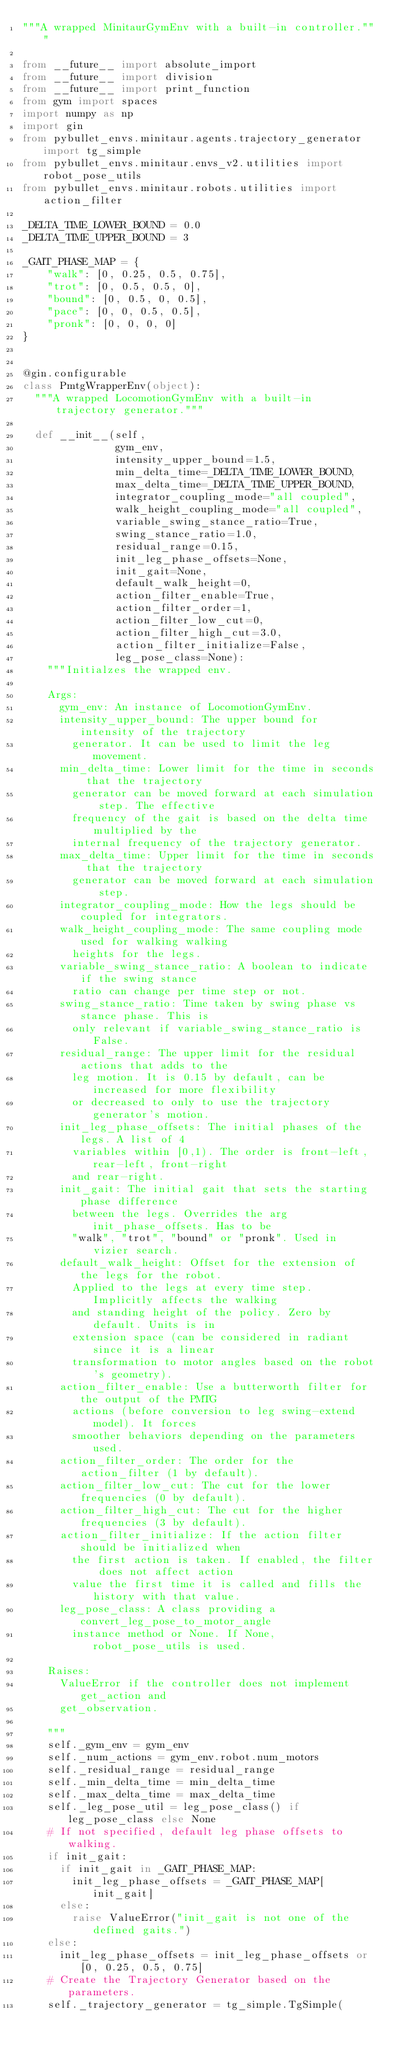<code> <loc_0><loc_0><loc_500><loc_500><_Python_>"""A wrapped MinitaurGymEnv with a built-in controller."""

from __future__ import absolute_import
from __future__ import division
from __future__ import print_function
from gym import spaces
import numpy as np
import gin
from pybullet_envs.minitaur.agents.trajectory_generator import tg_simple
from pybullet_envs.minitaur.envs_v2.utilities import robot_pose_utils
from pybullet_envs.minitaur.robots.utilities import action_filter

_DELTA_TIME_LOWER_BOUND = 0.0
_DELTA_TIME_UPPER_BOUND = 3

_GAIT_PHASE_MAP = {
    "walk": [0, 0.25, 0.5, 0.75],
    "trot": [0, 0.5, 0.5, 0],
    "bound": [0, 0.5, 0, 0.5],
    "pace": [0, 0, 0.5, 0.5],
    "pronk": [0, 0, 0, 0]
}


@gin.configurable
class PmtgWrapperEnv(object):
  """A wrapped LocomotionGymEnv with a built-in trajectory generator."""

  def __init__(self,
               gym_env,
               intensity_upper_bound=1.5,
               min_delta_time=_DELTA_TIME_LOWER_BOUND,
               max_delta_time=_DELTA_TIME_UPPER_BOUND,
               integrator_coupling_mode="all coupled",
               walk_height_coupling_mode="all coupled",
               variable_swing_stance_ratio=True,
               swing_stance_ratio=1.0,
               residual_range=0.15,
               init_leg_phase_offsets=None,
               init_gait=None,
               default_walk_height=0,
               action_filter_enable=True,
               action_filter_order=1,
               action_filter_low_cut=0,
               action_filter_high_cut=3.0,
               action_filter_initialize=False,
               leg_pose_class=None):
    """Initialzes the wrapped env.

    Args:
      gym_env: An instance of LocomotionGymEnv.
      intensity_upper_bound: The upper bound for intensity of the trajectory
        generator. It can be used to limit the leg movement.
      min_delta_time: Lower limit for the time in seconds that the trajectory
        generator can be moved forward at each simulation step. The effective
        frequency of the gait is based on the delta time multiplied by the
        internal frequency of the trajectory generator.
      max_delta_time: Upper limit for the time in seconds that the trajectory
        generator can be moved forward at each simulation step.
      integrator_coupling_mode: How the legs should be coupled for integrators.
      walk_height_coupling_mode: The same coupling mode used for walking walking
        heights for the legs.
      variable_swing_stance_ratio: A boolean to indicate if the swing stance
        ratio can change per time step or not.
      swing_stance_ratio: Time taken by swing phase vs stance phase. This is
        only relevant if variable_swing_stance_ratio is False.
      residual_range: The upper limit for the residual actions that adds to the
        leg motion. It is 0.15 by default, can be increased for more flexibility
        or decreased to only to use the trajectory generator's motion.
      init_leg_phase_offsets: The initial phases of the legs. A list of 4
        variables within [0,1). The order is front-left, rear-left, front-right
        and rear-right.
      init_gait: The initial gait that sets the starting phase difference
        between the legs. Overrides the arg init_phase_offsets. Has to be
        "walk", "trot", "bound" or "pronk". Used in vizier search.
      default_walk_height: Offset for the extension of the legs for the robot.
        Applied to the legs at every time step. Implicitly affects the walking
        and standing height of the policy. Zero by default. Units is in
        extension space (can be considered in radiant since it is a linear
        transformation to motor angles based on the robot's geometry).
      action_filter_enable: Use a butterworth filter for the output of the PMTG
        actions (before conversion to leg swing-extend model). It forces
        smoother behaviors depending on the parameters used.
      action_filter_order: The order for the action_filter (1 by default).
      action_filter_low_cut: The cut for the lower frequencies (0 by default).
      action_filter_high_cut: The cut for the higher frequencies (3 by default).
      action_filter_initialize: If the action filter should be initialized when
        the first action is taken. If enabled, the filter does not affect action
        value the first time it is called and fills the history with that value.
      leg_pose_class: A class providing a convert_leg_pose_to_motor_angle
        instance method or None. If None, robot_pose_utils is used.

    Raises:
      ValueError if the controller does not implement get_action and
      get_observation.

    """
    self._gym_env = gym_env
    self._num_actions = gym_env.robot.num_motors
    self._residual_range = residual_range
    self._min_delta_time = min_delta_time
    self._max_delta_time = max_delta_time
    self._leg_pose_util = leg_pose_class() if leg_pose_class else None
    # If not specified, default leg phase offsets to walking.
    if init_gait:
      if init_gait in _GAIT_PHASE_MAP:
        init_leg_phase_offsets = _GAIT_PHASE_MAP[init_gait]
      else:
        raise ValueError("init_gait is not one of the defined gaits.")
    else:
      init_leg_phase_offsets = init_leg_phase_offsets or [0, 0.25, 0.5, 0.75]
    # Create the Trajectory Generator based on the parameters.
    self._trajectory_generator = tg_simple.TgSimple(</code> 